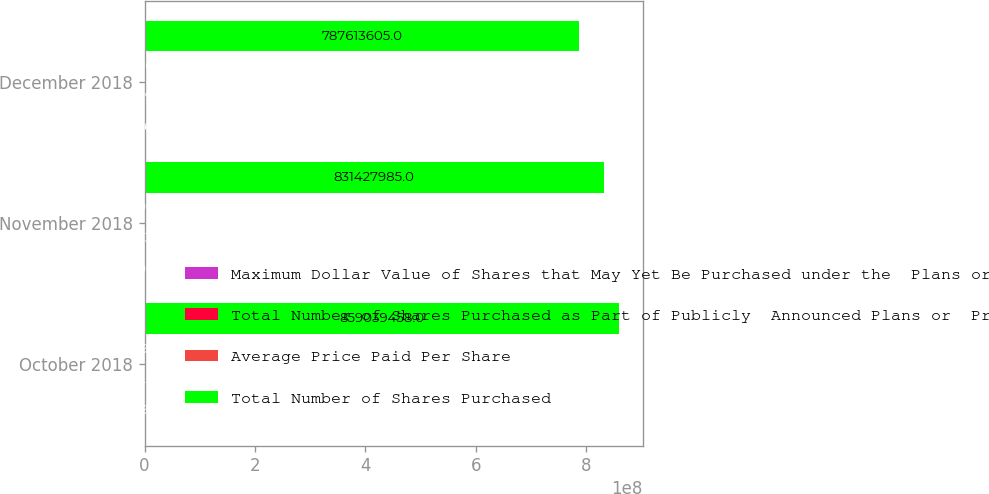<chart> <loc_0><loc_0><loc_500><loc_500><stacked_bar_chart><ecel><fcel>October 2018<fcel>November 2018<fcel>December 2018<nl><fcel>Maximum Dollar Value of Shares that May Yet Be Purchased under the  Plans or Programs<fcel>1.36099e+06<fcel>450000<fcel>912360<nl><fcel>Total Number of Shares Purchased as Part of Publicly  Announced Plans or  Programs<fcel>66.34<fcel>61.36<fcel>53.93<nl><fcel>Average Price Paid Per Share<fcel>1.36099e+06<fcel>450000<fcel>810000<nl><fcel>Total Number of Shares Purchased<fcel>8.59039e+08<fcel>8.31428e+08<fcel>7.87614e+08<nl></chart> 